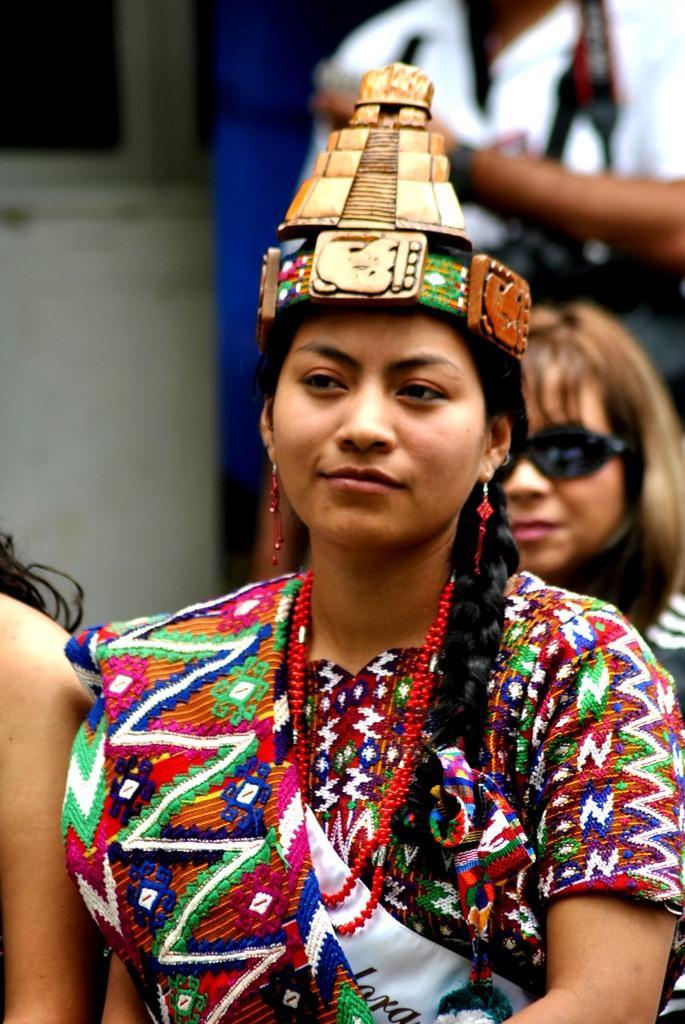Can you describe this image briefly? In this image we can see few people. A lady is wearing an object on her head. We can see a person wearing and holding someone objects at the top right corner of the image. 